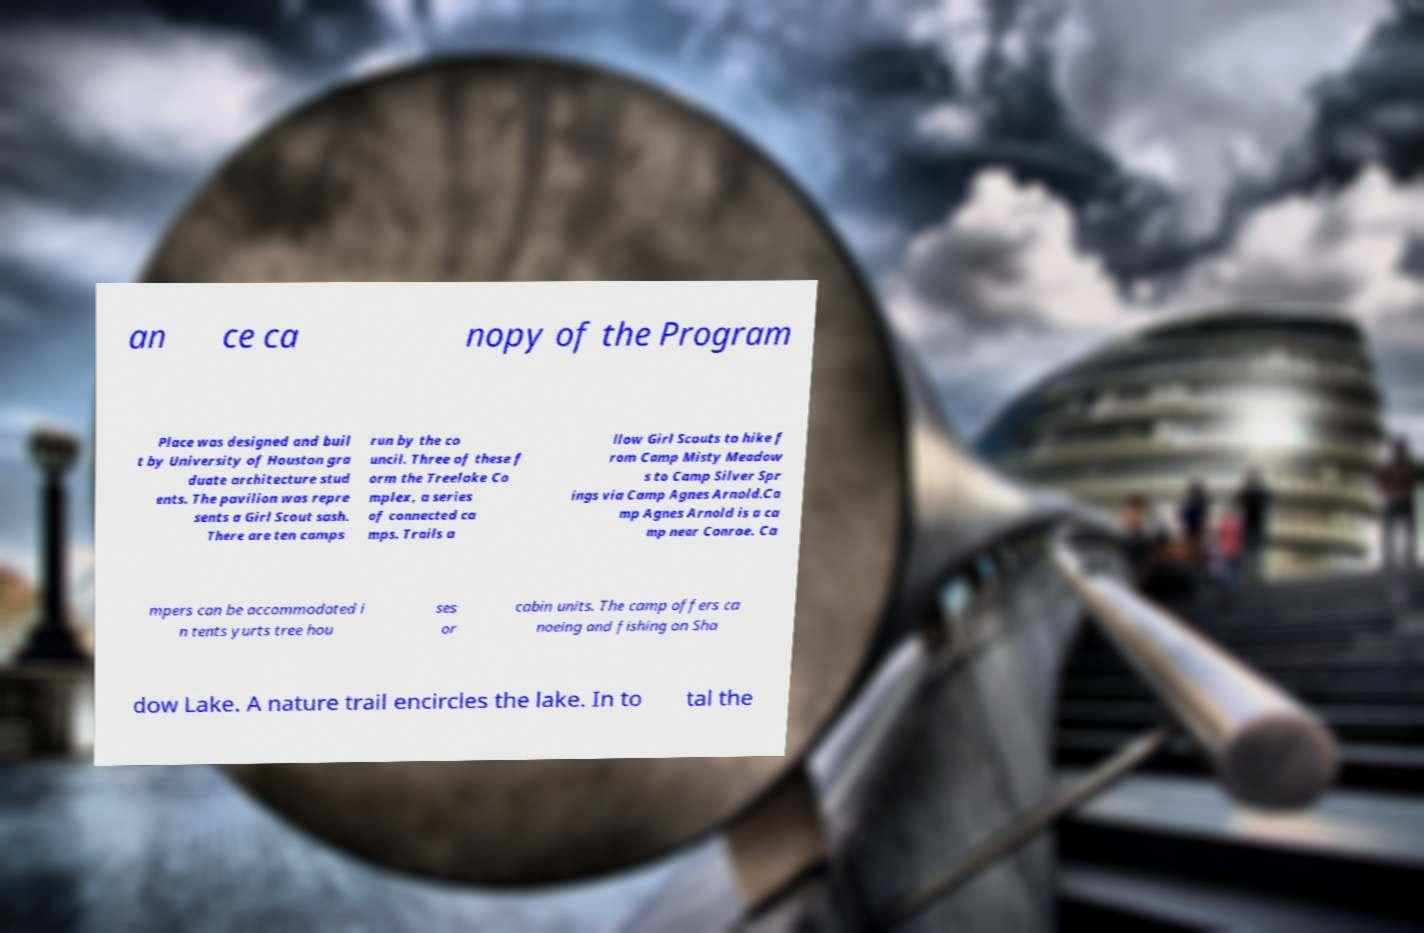I need the written content from this picture converted into text. Can you do that? an ce ca nopy of the Program Place was designed and buil t by University of Houston gra duate architecture stud ents. The pavilion was repre sents a Girl Scout sash. There are ten camps run by the co uncil. Three of these f orm the Treelake Co mplex, a series of connected ca mps. Trails a llow Girl Scouts to hike f rom Camp Misty Meadow s to Camp Silver Spr ings via Camp Agnes Arnold.Ca mp Agnes Arnold is a ca mp near Conroe. Ca mpers can be accommodated i n tents yurts tree hou ses or cabin units. The camp offers ca noeing and fishing on Sha dow Lake. A nature trail encircles the lake. In to tal the 